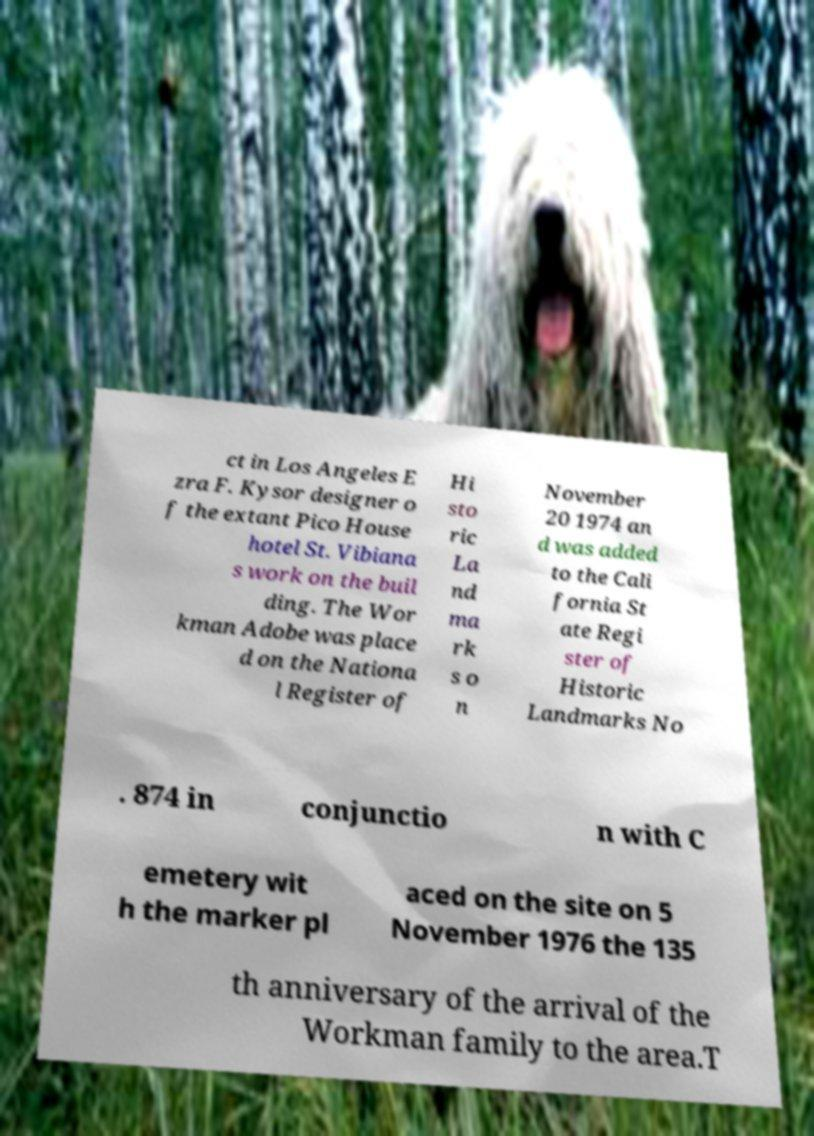There's text embedded in this image that I need extracted. Can you transcribe it verbatim? ct in Los Angeles E zra F. Kysor designer o f the extant Pico House hotel St. Vibiana s work on the buil ding. The Wor kman Adobe was place d on the Nationa l Register of Hi sto ric La nd ma rk s o n November 20 1974 an d was added to the Cali fornia St ate Regi ster of Historic Landmarks No . 874 in conjunctio n with C emetery wit h the marker pl aced on the site on 5 November 1976 the 135 th anniversary of the arrival of the Workman family to the area.T 